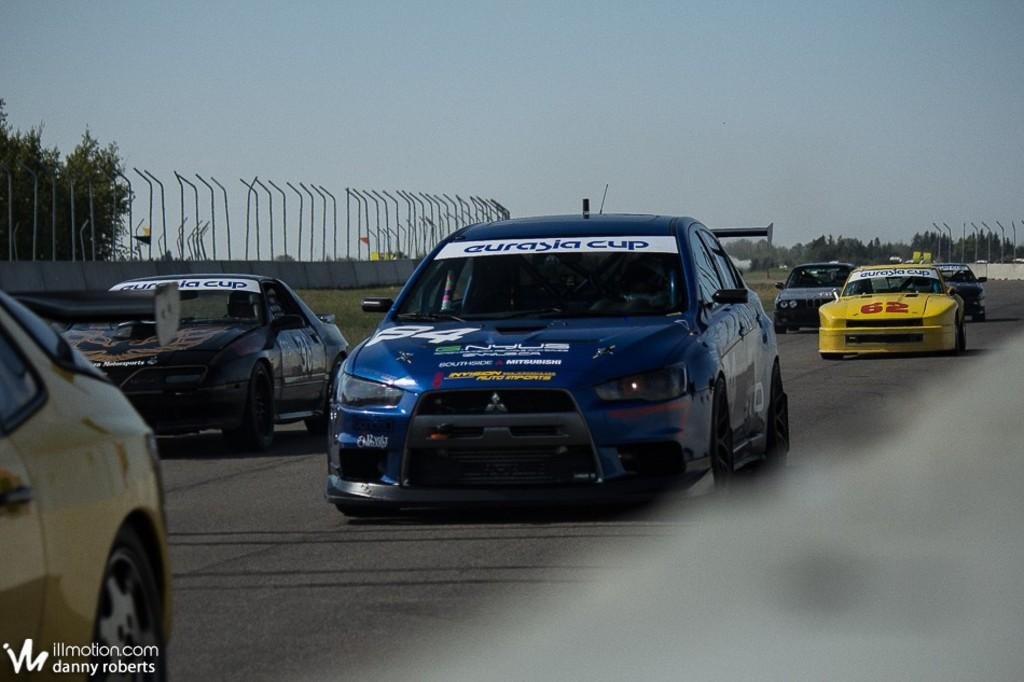What types of vehicles are present in the image? There are cars of different colors in the image. What other elements can be seen in the image besides the cars? There are trees and a wall visible in the image. What part of the natural environment is visible in the image? The sky is visible in the image. How many branches are on the trees in the image? The provided facts do not mention the number of branches on the trees, so it cannot be determined from the image. 